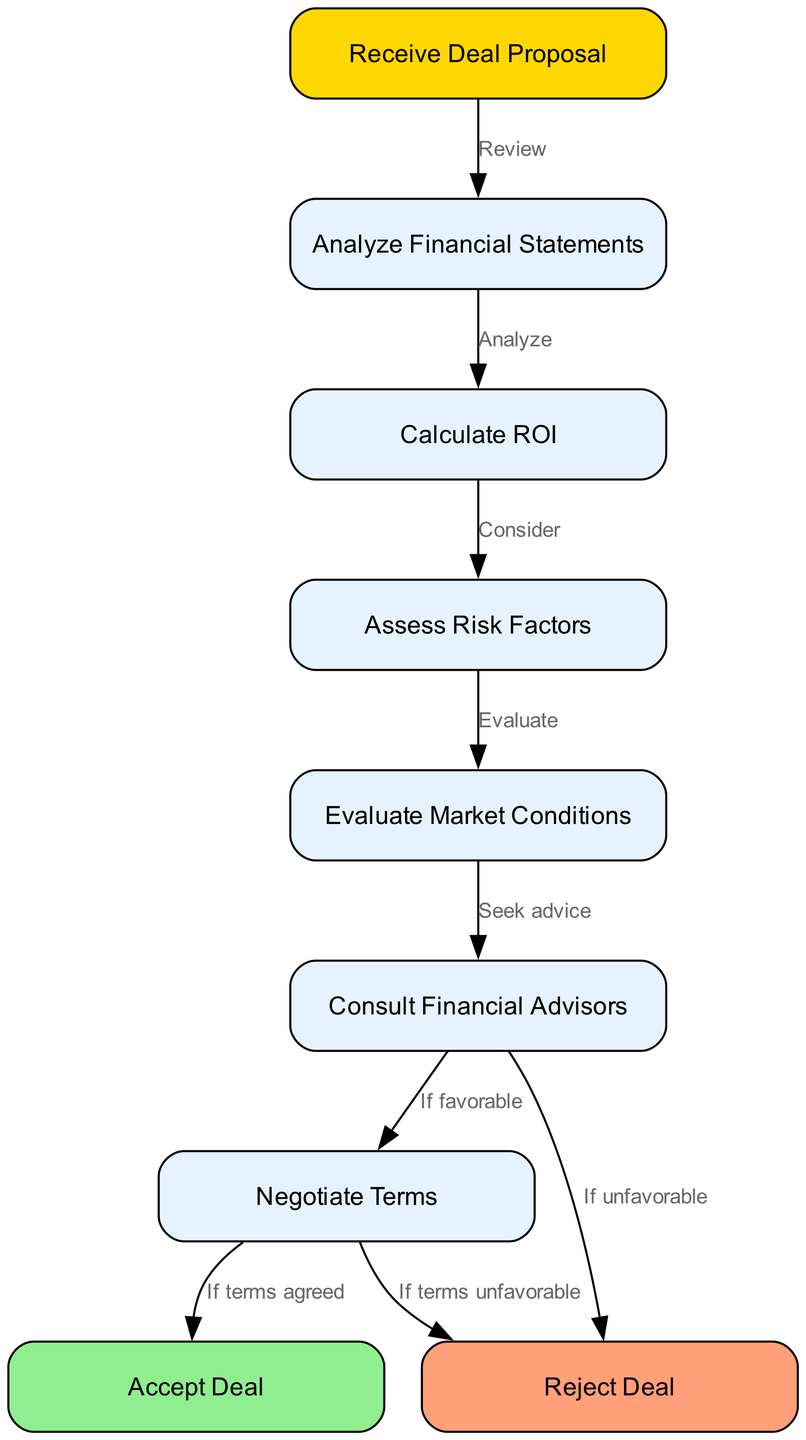What is the first step in the decision-making process? The first step in the flowchart is represented by the node "Receive Deal Proposal". This node is the starting point of the flow process where the evaluation begins.
Answer: Receive Deal Proposal How many nodes are there in total? By counting each of the distinct elements in the node list provided in the diagram, there are 9 nodes in total.
Answer: 9 What action follows "Analyze Financial Statements"? The diagram indicates an edge leading from "Analyze Financial Statements" to "Calculate ROI", which represents the next action that needs to be taken after the analysis of financial statements.
Answer: Calculate ROI What happens if the terms are unfavorable after negotiation? According to the flowchart, if the terms of the deal are unfavorable after negotiation, the process leads to the "Reject Deal" node, indicating that the deal will not be accepted.
Answer: Reject Deal Which node is connected to "Consult Financial Advisors"? The flowchart shows that "Consult Financial Advisors" connects to two possible outcomes: "Negotiate Terms" if the advice is favorable and "Reject Deal" if the advice is unfavorable. This illustrates the decision-making based on external advice.
Answer: Negotiate Terms and Reject Deal How many edges are there in the diagram? The edges represent the connections between the nodes, and by counting the number of connections listed in the edges data, there are 8 edges in total.
Answer: 8 What is the result of "If terms agreed" in the negotiation? The flowchart clearly states that if the terms are agreed upon during negotiation, the outcome leads to the "Accept Deal" node, confirming the decision to accept the financial deal.
Answer: Accept Deal What step precedes assessing risk factors? The diagram indicates a direct flow from "Calculate ROI" to "Assess Risk Factors", showing that the calculation of return on investment must be completed before assessing the risk involved in the deal.
Answer: Calculate ROI 